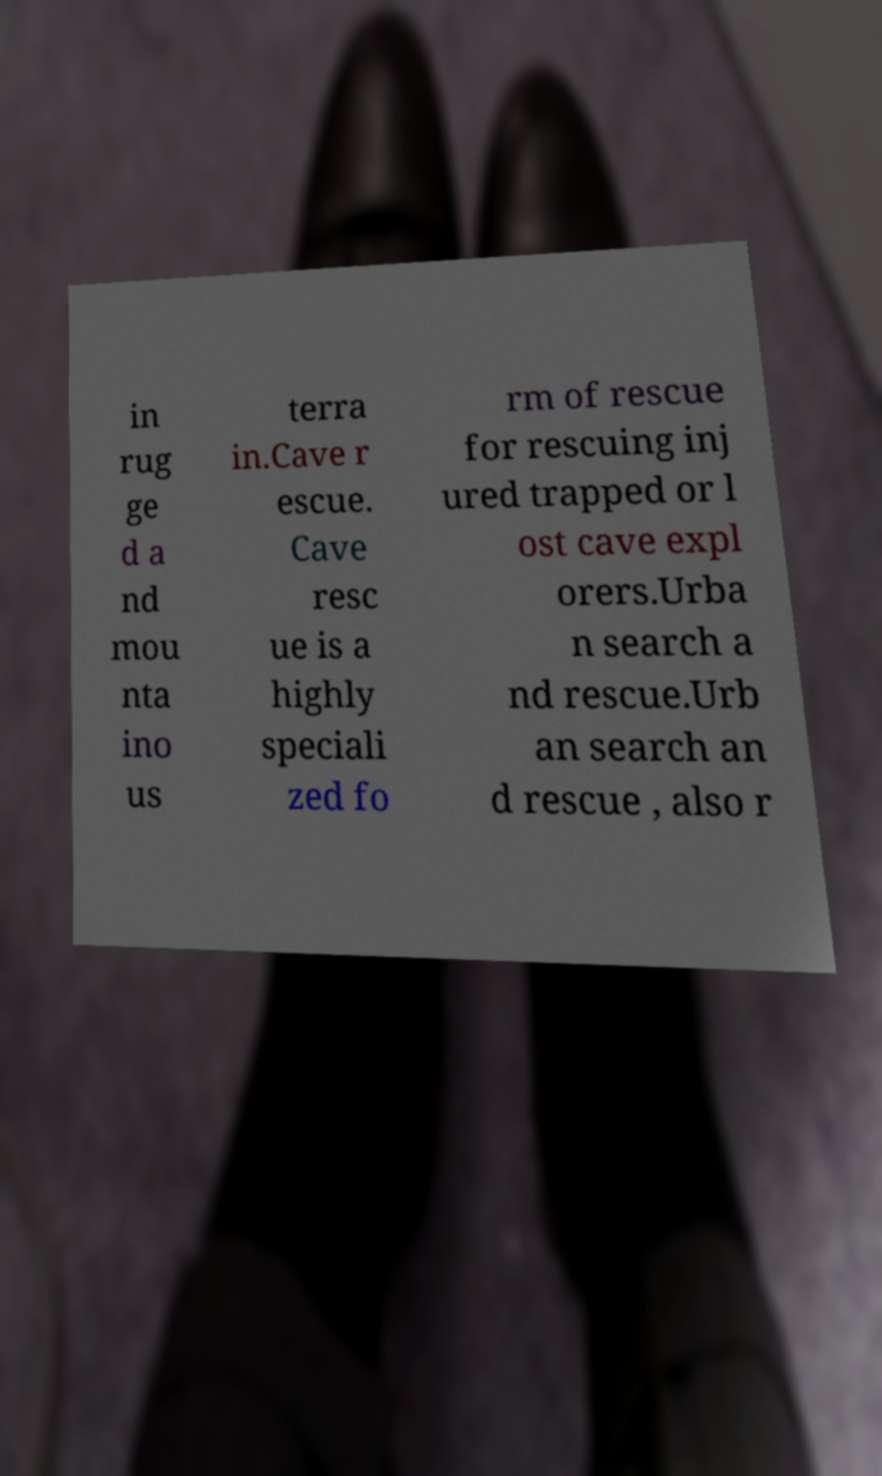For documentation purposes, I need the text within this image transcribed. Could you provide that? in rug ge d a nd mou nta ino us terra in.Cave r escue. Cave resc ue is a highly speciali zed fo rm of rescue for rescuing inj ured trapped or l ost cave expl orers.Urba n search a nd rescue.Urb an search an d rescue , also r 